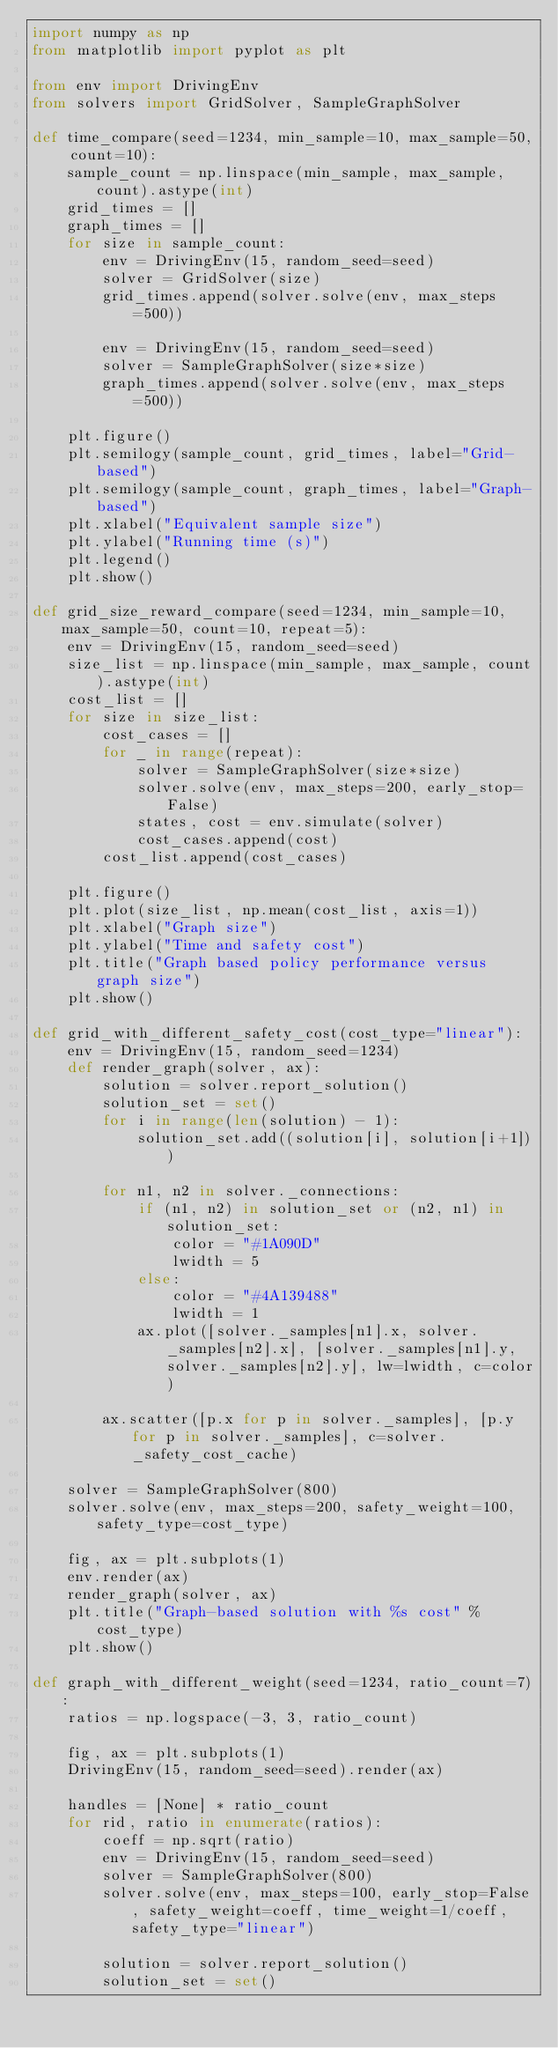<code> <loc_0><loc_0><loc_500><loc_500><_Python_>import numpy as np
from matplotlib import pyplot as plt

from env import DrivingEnv
from solvers import GridSolver, SampleGraphSolver

def time_compare(seed=1234, min_sample=10, max_sample=50, count=10):
    sample_count = np.linspace(min_sample, max_sample, count).astype(int)
    grid_times = []
    graph_times = []
    for size in sample_count:
        env = DrivingEnv(15, random_seed=seed)
        solver = GridSolver(size)
        grid_times.append(solver.solve(env, max_steps=500))

        env = DrivingEnv(15, random_seed=seed)
        solver = SampleGraphSolver(size*size)
        graph_times.append(solver.solve(env, max_steps=500))

    plt.figure()
    plt.semilogy(sample_count, grid_times, label="Grid-based")
    plt.semilogy(sample_count, graph_times, label="Graph-based")
    plt.xlabel("Equivalent sample size")
    plt.ylabel("Running time (s)")
    plt.legend()
    plt.show()

def grid_size_reward_compare(seed=1234, min_sample=10, max_sample=50, count=10, repeat=5):
    env = DrivingEnv(15, random_seed=seed)
    size_list = np.linspace(min_sample, max_sample, count).astype(int)
    cost_list = []
    for size in size_list:
        cost_cases = []
        for _ in range(repeat):
            solver = SampleGraphSolver(size*size)
            solver.solve(env, max_steps=200, early_stop=False)
            states, cost = env.simulate(solver)
            cost_cases.append(cost)
        cost_list.append(cost_cases)

    plt.figure()
    plt.plot(size_list, np.mean(cost_list, axis=1))
    plt.xlabel("Graph size")
    plt.ylabel("Time and safety cost")
    plt.title("Graph based policy performance versus graph size")
    plt.show()

def grid_with_different_safety_cost(cost_type="linear"):
    env = DrivingEnv(15, random_seed=1234)
    def render_graph(solver, ax):
        solution = solver.report_solution()
        solution_set = set()
        for i in range(len(solution) - 1):
            solution_set.add((solution[i], solution[i+1]))

        for n1, n2 in solver._connections:
            if (n1, n2) in solution_set or (n2, n1) in solution_set:
                color = "#1A090D"
                lwidth = 5
            else:
                color = "#4A139488"
                lwidth = 1
            ax.plot([solver._samples[n1].x, solver._samples[n2].x], [solver._samples[n1].y, solver._samples[n2].y], lw=lwidth, c=color)

        ax.scatter([p.x for p in solver._samples], [p.y for p in solver._samples], c=solver._safety_cost_cache)

    solver = SampleGraphSolver(800)
    solver.solve(env, max_steps=200, safety_weight=100, safety_type=cost_type)

    fig, ax = plt.subplots(1)
    env.render(ax)
    render_graph(solver, ax)
    plt.title("Graph-based solution with %s cost" % cost_type)
    plt.show()

def graph_with_different_weight(seed=1234, ratio_count=7):
    ratios = np.logspace(-3, 3, ratio_count)

    fig, ax = plt.subplots(1)
    DrivingEnv(15, random_seed=seed).render(ax)

    handles = [None] * ratio_count
    for rid, ratio in enumerate(ratios):
        coeff = np.sqrt(ratio)
        env = DrivingEnv(15, random_seed=seed)
        solver = SampleGraphSolver(800)
        solver.solve(env, max_steps=100, early_stop=False, safety_weight=coeff, time_weight=1/coeff, safety_type="linear")

        solution = solver.report_solution()
        solution_set = set()</code> 